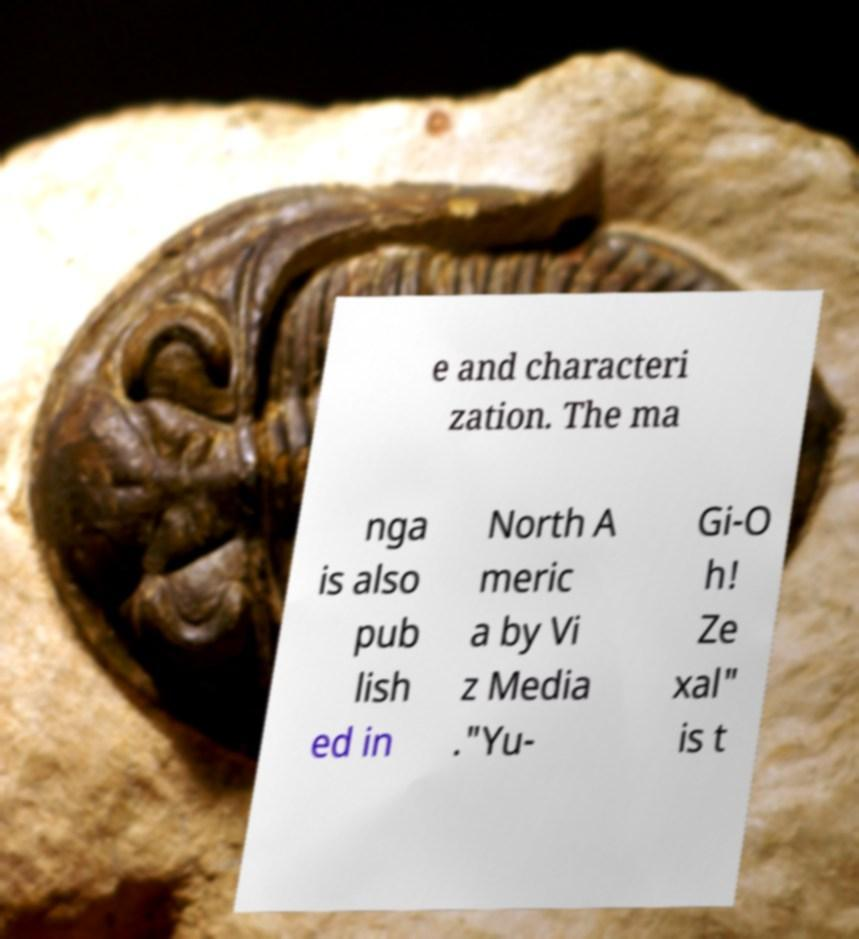I need the written content from this picture converted into text. Can you do that? e and characteri zation. The ma nga is also pub lish ed in North A meric a by Vi z Media ."Yu- Gi-O h! Ze xal" is t 